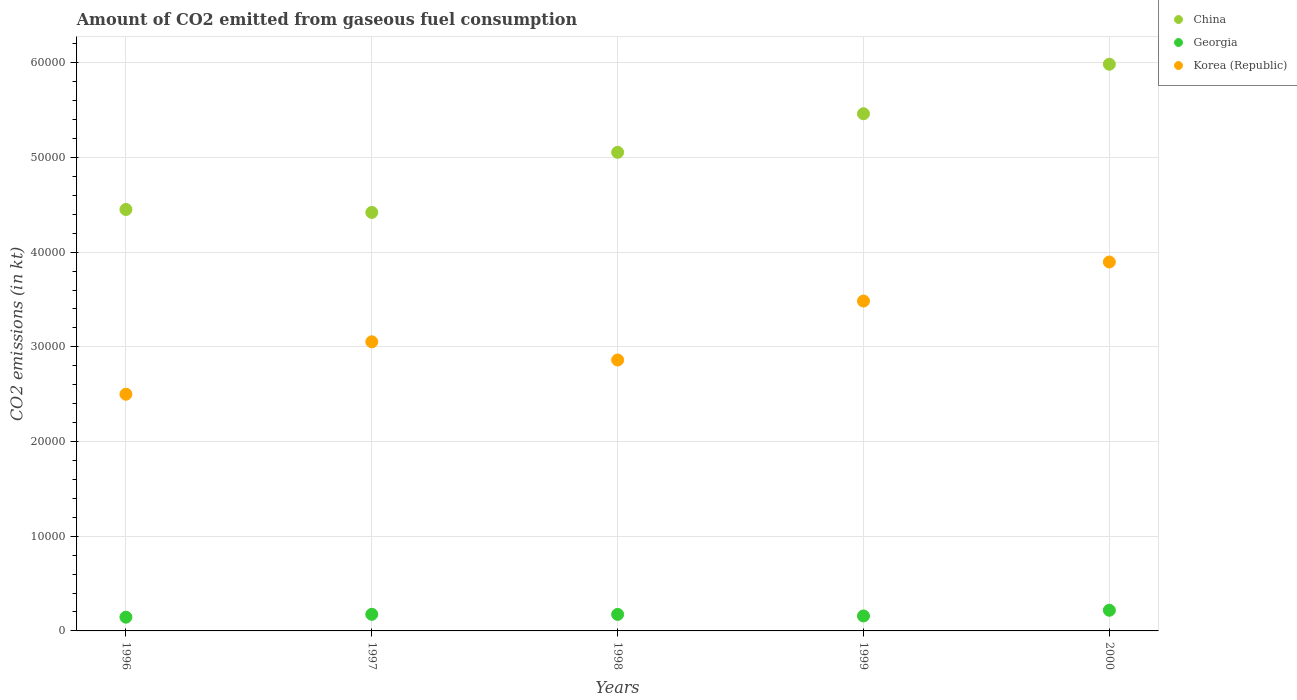Is the number of dotlines equal to the number of legend labels?
Give a very brief answer. Yes. What is the amount of CO2 emitted in Georgia in 1996?
Make the answer very short. 1452.13. Across all years, what is the maximum amount of CO2 emitted in Korea (Republic)?
Your answer should be compact. 3.90e+04. Across all years, what is the minimum amount of CO2 emitted in China?
Your response must be concise. 4.42e+04. In which year was the amount of CO2 emitted in Georgia maximum?
Your response must be concise. 2000. What is the total amount of CO2 emitted in China in the graph?
Your response must be concise. 2.54e+05. What is the difference between the amount of CO2 emitted in Georgia in 1996 and that in 1997?
Keep it short and to the point. -300.69. What is the difference between the amount of CO2 emitted in Georgia in 1997 and the amount of CO2 emitted in Korea (Republic) in 1999?
Provide a succinct answer. -3.31e+04. What is the average amount of CO2 emitted in China per year?
Ensure brevity in your answer.  5.07e+04. In the year 1996, what is the difference between the amount of CO2 emitted in Georgia and amount of CO2 emitted in China?
Your answer should be very brief. -4.31e+04. Is the amount of CO2 emitted in Korea (Republic) in 1996 less than that in 1999?
Keep it short and to the point. Yes. Is the difference between the amount of CO2 emitted in Georgia in 1996 and 1998 greater than the difference between the amount of CO2 emitted in China in 1996 and 1998?
Make the answer very short. Yes. What is the difference between the highest and the second highest amount of CO2 emitted in Georgia?
Offer a very short reply. 429.04. What is the difference between the highest and the lowest amount of CO2 emitted in Korea (Republic)?
Ensure brevity in your answer.  1.40e+04. Is it the case that in every year, the sum of the amount of CO2 emitted in Korea (Republic) and amount of CO2 emitted in China  is greater than the amount of CO2 emitted in Georgia?
Give a very brief answer. Yes. Does the amount of CO2 emitted in Korea (Republic) monotonically increase over the years?
Make the answer very short. No. Does the graph contain any zero values?
Offer a very short reply. No. Does the graph contain grids?
Provide a succinct answer. Yes. Where does the legend appear in the graph?
Provide a short and direct response. Top right. How many legend labels are there?
Your answer should be very brief. 3. How are the legend labels stacked?
Offer a terse response. Vertical. What is the title of the graph?
Your answer should be compact. Amount of CO2 emitted from gaseous fuel consumption. What is the label or title of the Y-axis?
Your response must be concise. CO2 emissions (in kt). What is the CO2 emissions (in kt) of China in 1996?
Offer a very short reply. 4.45e+04. What is the CO2 emissions (in kt) of Georgia in 1996?
Offer a terse response. 1452.13. What is the CO2 emissions (in kt) of Korea (Republic) in 1996?
Ensure brevity in your answer.  2.50e+04. What is the CO2 emissions (in kt) in China in 1997?
Your response must be concise. 4.42e+04. What is the CO2 emissions (in kt) in Georgia in 1997?
Provide a short and direct response. 1752.83. What is the CO2 emissions (in kt) in Korea (Republic) in 1997?
Your response must be concise. 3.05e+04. What is the CO2 emissions (in kt) in China in 1998?
Make the answer very short. 5.05e+04. What is the CO2 emissions (in kt) in Georgia in 1998?
Give a very brief answer. 1745.49. What is the CO2 emissions (in kt) of Korea (Republic) in 1998?
Keep it short and to the point. 2.86e+04. What is the CO2 emissions (in kt) of China in 1999?
Your answer should be very brief. 5.46e+04. What is the CO2 emissions (in kt) of Georgia in 1999?
Provide a short and direct response. 1580.48. What is the CO2 emissions (in kt) in Korea (Republic) in 1999?
Offer a very short reply. 3.48e+04. What is the CO2 emissions (in kt) in China in 2000?
Provide a succinct answer. 5.98e+04. What is the CO2 emissions (in kt) in Georgia in 2000?
Your answer should be very brief. 2181.86. What is the CO2 emissions (in kt) of Korea (Republic) in 2000?
Your answer should be compact. 3.90e+04. Across all years, what is the maximum CO2 emissions (in kt) in China?
Your answer should be compact. 5.98e+04. Across all years, what is the maximum CO2 emissions (in kt) of Georgia?
Make the answer very short. 2181.86. Across all years, what is the maximum CO2 emissions (in kt) of Korea (Republic)?
Keep it short and to the point. 3.90e+04. Across all years, what is the minimum CO2 emissions (in kt) of China?
Provide a short and direct response. 4.42e+04. Across all years, what is the minimum CO2 emissions (in kt) of Georgia?
Keep it short and to the point. 1452.13. Across all years, what is the minimum CO2 emissions (in kt) in Korea (Republic)?
Provide a short and direct response. 2.50e+04. What is the total CO2 emissions (in kt) in China in the graph?
Offer a very short reply. 2.54e+05. What is the total CO2 emissions (in kt) of Georgia in the graph?
Provide a succinct answer. 8712.79. What is the total CO2 emissions (in kt) of Korea (Republic) in the graph?
Keep it short and to the point. 1.58e+05. What is the difference between the CO2 emissions (in kt) in China in 1996 and that in 1997?
Make the answer very short. 311.69. What is the difference between the CO2 emissions (in kt) in Georgia in 1996 and that in 1997?
Your answer should be very brief. -300.69. What is the difference between the CO2 emissions (in kt) in Korea (Republic) in 1996 and that in 1997?
Make the answer very short. -5533.5. What is the difference between the CO2 emissions (in kt) of China in 1996 and that in 1998?
Provide a short and direct response. -6035.88. What is the difference between the CO2 emissions (in kt) in Georgia in 1996 and that in 1998?
Make the answer very short. -293.36. What is the difference between the CO2 emissions (in kt) in Korea (Republic) in 1996 and that in 1998?
Your response must be concise. -3611.99. What is the difference between the CO2 emissions (in kt) in China in 1996 and that in 1999?
Offer a very short reply. -1.01e+04. What is the difference between the CO2 emissions (in kt) of Georgia in 1996 and that in 1999?
Keep it short and to the point. -128.34. What is the difference between the CO2 emissions (in kt) of Korea (Republic) in 1996 and that in 1999?
Your answer should be compact. -9838.56. What is the difference between the CO2 emissions (in kt) of China in 1996 and that in 2000?
Your answer should be very brief. -1.53e+04. What is the difference between the CO2 emissions (in kt) in Georgia in 1996 and that in 2000?
Your answer should be very brief. -729.73. What is the difference between the CO2 emissions (in kt) of Korea (Republic) in 1996 and that in 2000?
Your answer should be compact. -1.40e+04. What is the difference between the CO2 emissions (in kt) in China in 1997 and that in 1998?
Offer a terse response. -6347.58. What is the difference between the CO2 emissions (in kt) of Georgia in 1997 and that in 1998?
Keep it short and to the point. 7.33. What is the difference between the CO2 emissions (in kt) in Korea (Republic) in 1997 and that in 1998?
Ensure brevity in your answer.  1921.51. What is the difference between the CO2 emissions (in kt) in China in 1997 and that in 1999?
Offer a terse response. -1.04e+04. What is the difference between the CO2 emissions (in kt) of Georgia in 1997 and that in 1999?
Offer a very short reply. 172.35. What is the difference between the CO2 emissions (in kt) in Korea (Republic) in 1997 and that in 1999?
Keep it short and to the point. -4305.06. What is the difference between the CO2 emissions (in kt) in China in 1997 and that in 2000?
Offer a very short reply. -1.57e+04. What is the difference between the CO2 emissions (in kt) of Georgia in 1997 and that in 2000?
Give a very brief answer. -429.04. What is the difference between the CO2 emissions (in kt) of Korea (Republic) in 1997 and that in 2000?
Give a very brief answer. -8426.77. What is the difference between the CO2 emissions (in kt) in China in 1998 and that in 1999?
Ensure brevity in your answer.  -4074.04. What is the difference between the CO2 emissions (in kt) in Georgia in 1998 and that in 1999?
Make the answer very short. 165.01. What is the difference between the CO2 emissions (in kt) in Korea (Republic) in 1998 and that in 1999?
Provide a short and direct response. -6226.57. What is the difference between the CO2 emissions (in kt) of China in 1998 and that in 2000?
Your answer should be very brief. -9303.18. What is the difference between the CO2 emissions (in kt) of Georgia in 1998 and that in 2000?
Provide a short and direct response. -436.37. What is the difference between the CO2 emissions (in kt) of Korea (Republic) in 1998 and that in 2000?
Make the answer very short. -1.03e+04. What is the difference between the CO2 emissions (in kt) of China in 1999 and that in 2000?
Give a very brief answer. -5229.14. What is the difference between the CO2 emissions (in kt) of Georgia in 1999 and that in 2000?
Ensure brevity in your answer.  -601.39. What is the difference between the CO2 emissions (in kt) in Korea (Republic) in 1999 and that in 2000?
Give a very brief answer. -4121.71. What is the difference between the CO2 emissions (in kt) of China in 1996 and the CO2 emissions (in kt) of Georgia in 1997?
Provide a succinct answer. 4.28e+04. What is the difference between the CO2 emissions (in kt) in China in 1996 and the CO2 emissions (in kt) in Korea (Republic) in 1997?
Provide a short and direct response. 1.40e+04. What is the difference between the CO2 emissions (in kt) in Georgia in 1996 and the CO2 emissions (in kt) in Korea (Republic) in 1997?
Offer a very short reply. -2.91e+04. What is the difference between the CO2 emissions (in kt) of China in 1996 and the CO2 emissions (in kt) of Georgia in 1998?
Keep it short and to the point. 4.28e+04. What is the difference between the CO2 emissions (in kt) in China in 1996 and the CO2 emissions (in kt) in Korea (Republic) in 1998?
Offer a very short reply. 1.59e+04. What is the difference between the CO2 emissions (in kt) in Georgia in 1996 and the CO2 emissions (in kt) in Korea (Republic) in 1998?
Offer a terse response. -2.72e+04. What is the difference between the CO2 emissions (in kt) in China in 1996 and the CO2 emissions (in kt) in Georgia in 1999?
Your answer should be very brief. 4.29e+04. What is the difference between the CO2 emissions (in kt) in China in 1996 and the CO2 emissions (in kt) in Korea (Republic) in 1999?
Keep it short and to the point. 9669.88. What is the difference between the CO2 emissions (in kt) in Georgia in 1996 and the CO2 emissions (in kt) in Korea (Republic) in 1999?
Ensure brevity in your answer.  -3.34e+04. What is the difference between the CO2 emissions (in kt) of China in 1996 and the CO2 emissions (in kt) of Georgia in 2000?
Make the answer very short. 4.23e+04. What is the difference between the CO2 emissions (in kt) of China in 1996 and the CO2 emissions (in kt) of Korea (Republic) in 2000?
Provide a succinct answer. 5548.17. What is the difference between the CO2 emissions (in kt) of Georgia in 1996 and the CO2 emissions (in kt) of Korea (Republic) in 2000?
Provide a short and direct response. -3.75e+04. What is the difference between the CO2 emissions (in kt) of China in 1997 and the CO2 emissions (in kt) of Georgia in 1998?
Your response must be concise. 4.24e+04. What is the difference between the CO2 emissions (in kt) of China in 1997 and the CO2 emissions (in kt) of Korea (Republic) in 1998?
Your response must be concise. 1.56e+04. What is the difference between the CO2 emissions (in kt) of Georgia in 1997 and the CO2 emissions (in kt) of Korea (Republic) in 1998?
Provide a short and direct response. -2.69e+04. What is the difference between the CO2 emissions (in kt) in China in 1997 and the CO2 emissions (in kt) in Georgia in 1999?
Make the answer very short. 4.26e+04. What is the difference between the CO2 emissions (in kt) in China in 1997 and the CO2 emissions (in kt) in Korea (Republic) in 1999?
Offer a terse response. 9358.18. What is the difference between the CO2 emissions (in kt) of Georgia in 1997 and the CO2 emissions (in kt) of Korea (Republic) in 1999?
Offer a terse response. -3.31e+04. What is the difference between the CO2 emissions (in kt) of China in 1997 and the CO2 emissions (in kt) of Georgia in 2000?
Ensure brevity in your answer.  4.20e+04. What is the difference between the CO2 emissions (in kt) of China in 1997 and the CO2 emissions (in kt) of Korea (Republic) in 2000?
Provide a short and direct response. 5236.48. What is the difference between the CO2 emissions (in kt) in Georgia in 1997 and the CO2 emissions (in kt) in Korea (Republic) in 2000?
Offer a terse response. -3.72e+04. What is the difference between the CO2 emissions (in kt) of China in 1998 and the CO2 emissions (in kt) of Georgia in 1999?
Your answer should be very brief. 4.90e+04. What is the difference between the CO2 emissions (in kt) of China in 1998 and the CO2 emissions (in kt) of Korea (Republic) in 1999?
Your response must be concise. 1.57e+04. What is the difference between the CO2 emissions (in kt) of Georgia in 1998 and the CO2 emissions (in kt) of Korea (Republic) in 1999?
Provide a short and direct response. -3.31e+04. What is the difference between the CO2 emissions (in kt) of China in 1998 and the CO2 emissions (in kt) of Georgia in 2000?
Your response must be concise. 4.84e+04. What is the difference between the CO2 emissions (in kt) of China in 1998 and the CO2 emissions (in kt) of Korea (Republic) in 2000?
Your answer should be very brief. 1.16e+04. What is the difference between the CO2 emissions (in kt) in Georgia in 1998 and the CO2 emissions (in kt) in Korea (Republic) in 2000?
Keep it short and to the point. -3.72e+04. What is the difference between the CO2 emissions (in kt) of China in 1999 and the CO2 emissions (in kt) of Georgia in 2000?
Offer a terse response. 5.24e+04. What is the difference between the CO2 emissions (in kt) of China in 1999 and the CO2 emissions (in kt) of Korea (Republic) in 2000?
Ensure brevity in your answer.  1.57e+04. What is the difference between the CO2 emissions (in kt) in Georgia in 1999 and the CO2 emissions (in kt) in Korea (Republic) in 2000?
Make the answer very short. -3.74e+04. What is the average CO2 emissions (in kt) in China per year?
Make the answer very short. 5.07e+04. What is the average CO2 emissions (in kt) of Georgia per year?
Ensure brevity in your answer.  1742.56. What is the average CO2 emissions (in kt) of Korea (Republic) per year?
Offer a terse response. 3.16e+04. In the year 1996, what is the difference between the CO2 emissions (in kt) in China and CO2 emissions (in kt) in Georgia?
Your answer should be compact. 4.31e+04. In the year 1996, what is the difference between the CO2 emissions (in kt) of China and CO2 emissions (in kt) of Korea (Republic)?
Keep it short and to the point. 1.95e+04. In the year 1996, what is the difference between the CO2 emissions (in kt) in Georgia and CO2 emissions (in kt) in Korea (Republic)?
Provide a short and direct response. -2.35e+04. In the year 1997, what is the difference between the CO2 emissions (in kt) of China and CO2 emissions (in kt) of Georgia?
Offer a terse response. 4.24e+04. In the year 1997, what is the difference between the CO2 emissions (in kt) of China and CO2 emissions (in kt) of Korea (Republic)?
Provide a short and direct response. 1.37e+04. In the year 1997, what is the difference between the CO2 emissions (in kt) of Georgia and CO2 emissions (in kt) of Korea (Republic)?
Give a very brief answer. -2.88e+04. In the year 1998, what is the difference between the CO2 emissions (in kt) in China and CO2 emissions (in kt) in Georgia?
Offer a very short reply. 4.88e+04. In the year 1998, what is the difference between the CO2 emissions (in kt) of China and CO2 emissions (in kt) of Korea (Republic)?
Provide a succinct answer. 2.19e+04. In the year 1998, what is the difference between the CO2 emissions (in kt) of Georgia and CO2 emissions (in kt) of Korea (Republic)?
Your response must be concise. -2.69e+04. In the year 1999, what is the difference between the CO2 emissions (in kt) of China and CO2 emissions (in kt) of Georgia?
Provide a short and direct response. 5.30e+04. In the year 1999, what is the difference between the CO2 emissions (in kt) in China and CO2 emissions (in kt) in Korea (Republic)?
Keep it short and to the point. 1.98e+04. In the year 1999, what is the difference between the CO2 emissions (in kt) in Georgia and CO2 emissions (in kt) in Korea (Republic)?
Provide a short and direct response. -3.33e+04. In the year 2000, what is the difference between the CO2 emissions (in kt) of China and CO2 emissions (in kt) of Georgia?
Provide a short and direct response. 5.77e+04. In the year 2000, what is the difference between the CO2 emissions (in kt) of China and CO2 emissions (in kt) of Korea (Republic)?
Provide a succinct answer. 2.09e+04. In the year 2000, what is the difference between the CO2 emissions (in kt) in Georgia and CO2 emissions (in kt) in Korea (Republic)?
Give a very brief answer. -3.68e+04. What is the ratio of the CO2 emissions (in kt) in China in 1996 to that in 1997?
Give a very brief answer. 1.01. What is the ratio of the CO2 emissions (in kt) in Georgia in 1996 to that in 1997?
Your answer should be compact. 0.83. What is the ratio of the CO2 emissions (in kt) in Korea (Republic) in 1996 to that in 1997?
Offer a very short reply. 0.82. What is the ratio of the CO2 emissions (in kt) in China in 1996 to that in 1998?
Provide a short and direct response. 0.88. What is the ratio of the CO2 emissions (in kt) in Georgia in 1996 to that in 1998?
Your answer should be compact. 0.83. What is the ratio of the CO2 emissions (in kt) in Korea (Republic) in 1996 to that in 1998?
Provide a succinct answer. 0.87. What is the ratio of the CO2 emissions (in kt) of China in 1996 to that in 1999?
Provide a succinct answer. 0.81. What is the ratio of the CO2 emissions (in kt) of Georgia in 1996 to that in 1999?
Make the answer very short. 0.92. What is the ratio of the CO2 emissions (in kt) of Korea (Republic) in 1996 to that in 1999?
Give a very brief answer. 0.72. What is the ratio of the CO2 emissions (in kt) of China in 1996 to that in 2000?
Your response must be concise. 0.74. What is the ratio of the CO2 emissions (in kt) of Georgia in 1996 to that in 2000?
Your answer should be compact. 0.67. What is the ratio of the CO2 emissions (in kt) in Korea (Republic) in 1996 to that in 2000?
Ensure brevity in your answer.  0.64. What is the ratio of the CO2 emissions (in kt) of China in 1997 to that in 1998?
Provide a short and direct response. 0.87. What is the ratio of the CO2 emissions (in kt) of Korea (Republic) in 1997 to that in 1998?
Your response must be concise. 1.07. What is the ratio of the CO2 emissions (in kt) of China in 1997 to that in 1999?
Your answer should be compact. 0.81. What is the ratio of the CO2 emissions (in kt) in Georgia in 1997 to that in 1999?
Offer a very short reply. 1.11. What is the ratio of the CO2 emissions (in kt) of Korea (Republic) in 1997 to that in 1999?
Keep it short and to the point. 0.88. What is the ratio of the CO2 emissions (in kt) in China in 1997 to that in 2000?
Provide a short and direct response. 0.74. What is the ratio of the CO2 emissions (in kt) of Georgia in 1997 to that in 2000?
Your answer should be very brief. 0.8. What is the ratio of the CO2 emissions (in kt) of Korea (Republic) in 1997 to that in 2000?
Give a very brief answer. 0.78. What is the ratio of the CO2 emissions (in kt) in China in 1998 to that in 1999?
Provide a succinct answer. 0.93. What is the ratio of the CO2 emissions (in kt) of Georgia in 1998 to that in 1999?
Your answer should be compact. 1.1. What is the ratio of the CO2 emissions (in kt) in Korea (Republic) in 1998 to that in 1999?
Provide a succinct answer. 0.82. What is the ratio of the CO2 emissions (in kt) of China in 1998 to that in 2000?
Make the answer very short. 0.84. What is the ratio of the CO2 emissions (in kt) in Korea (Republic) in 1998 to that in 2000?
Your answer should be compact. 0.73. What is the ratio of the CO2 emissions (in kt) of China in 1999 to that in 2000?
Provide a succinct answer. 0.91. What is the ratio of the CO2 emissions (in kt) of Georgia in 1999 to that in 2000?
Keep it short and to the point. 0.72. What is the ratio of the CO2 emissions (in kt) of Korea (Republic) in 1999 to that in 2000?
Ensure brevity in your answer.  0.89. What is the difference between the highest and the second highest CO2 emissions (in kt) in China?
Give a very brief answer. 5229.14. What is the difference between the highest and the second highest CO2 emissions (in kt) of Georgia?
Provide a succinct answer. 429.04. What is the difference between the highest and the second highest CO2 emissions (in kt) in Korea (Republic)?
Offer a very short reply. 4121.71. What is the difference between the highest and the lowest CO2 emissions (in kt) of China?
Ensure brevity in your answer.  1.57e+04. What is the difference between the highest and the lowest CO2 emissions (in kt) in Georgia?
Provide a succinct answer. 729.73. What is the difference between the highest and the lowest CO2 emissions (in kt) of Korea (Republic)?
Your response must be concise. 1.40e+04. 